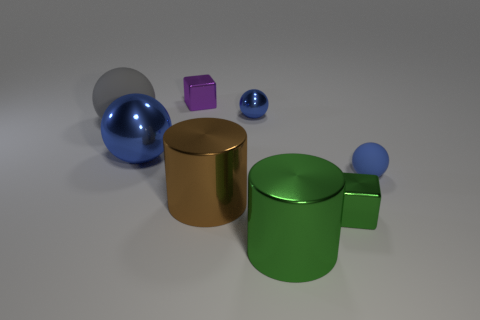What number of other objects are the same size as the green metallic block?
Ensure brevity in your answer.  3. Is the color of the big metal sphere the same as the matte ball that is on the right side of the big brown cylinder?
Give a very brief answer. Yes. Are there fewer tiny blue objects that are left of the small rubber ball than large things on the left side of the brown shiny object?
Offer a terse response. Yes. There is a ball that is both on the right side of the large blue sphere and left of the tiny green cube; what is its color?
Offer a very short reply. Blue. Do the green metal cylinder and the blue rubber ball in front of the gray rubber sphere have the same size?
Your response must be concise. No. There is a blue thing that is behind the big metal sphere; what shape is it?
Give a very brief answer. Sphere. Is the number of tiny blue metal spheres that are behind the brown metallic cylinder greater than the number of tiny brown balls?
Keep it short and to the point. Yes. There is a object in front of the tiny shiny cube that is in front of the purple block; what number of tiny metallic things are behind it?
Keep it short and to the point. 3. There is a shiny ball to the left of the tiny blue metal ball; does it have the same size as the blue thing behind the big gray thing?
Your answer should be very brief. No. What is the cylinder that is on the right side of the cylinder that is behind the small green metal object made of?
Make the answer very short. Metal. 